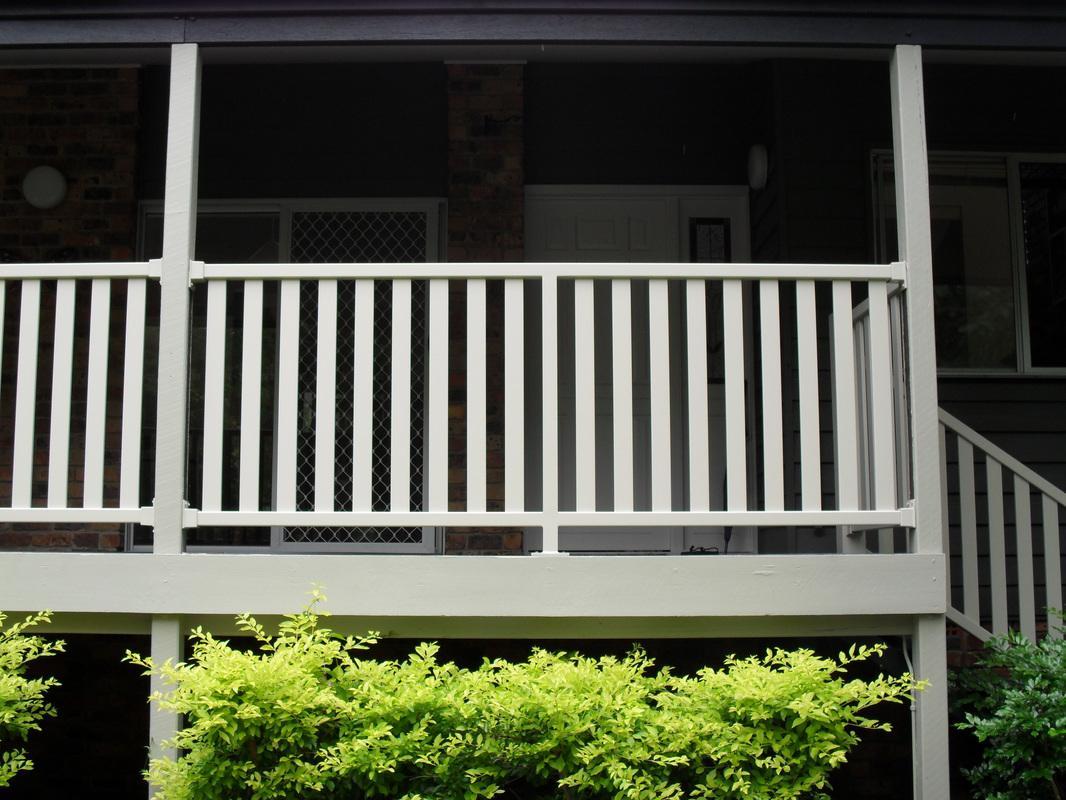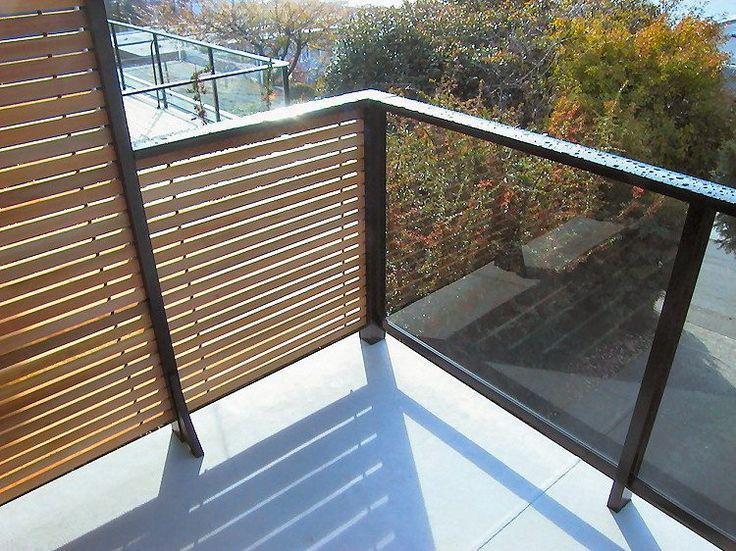The first image is the image on the left, the second image is the image on the right. Evaluate the accuracy of this statement regarding the images: "The balcony in the left image has close-together horizontal boards for rails, and the balcony on the right has vertical white bars for rails.". Is it true? Answer yes or no. No. The first image is the image on the left, the second image is the image on the right. Analyze the images presented: Is the assertion "There are are least three colored poles in between a white balcony fence." valid? Answer yes or no. No. 